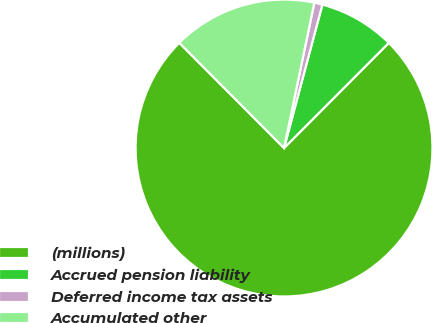<chart> <loc_0><loc_0><loc_500><loc_500><pie_chart><fcel>(millions)<fcel>Accrued pension liability<fcel>Deferred income tax assets<fcel>Accumulated other<nl><fcel>75.07%<fcel>8.31%<fcel>0.89%<fcel>15.73%<nl></chart> 